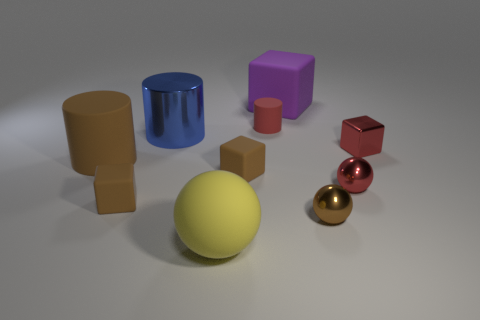There is a small cylinder that is the same color as the tiny shiny block; what is its material?
Your answer should be compact. Rubber. Is the number of tiny brown rubber blocks less than the number of big gray matte spheres?
Give a very brief answer. No. There is another small metallic object that is the same shape as the purple object; what color is it?
Provide a short and direct response. Red. Are there more purple blocks than tiny matte blocks?
Offer a terse response. No. How many other things are there of the same material as the tiny red cube?
Keep it short and to the point. 3. There is a tiny red metallic thing that is in front of the small red metal thing behind the big object left of the large blue metallic object; what shape is it?
Your response must be concise. Sphere. Are there fewer metallic objects that are on the right side of the big yellow rubber ball than objects on the left side of the small brown ball?
Ensure brevity in your answer.  Yes. Are there any tiny rubber objects of the same color as the big matte cylinder?
Your answer should be compact. Yes. Are the tiny brown ball and the tiny red sphere that is in front of the tiny red cylinder made of the same material?
Your answer should be very brief. Yes. There is a large rubber object in front of the big brown matte cylinder; is there a tiny red metal sphere in front of it?
Give a very brief answer. No. 